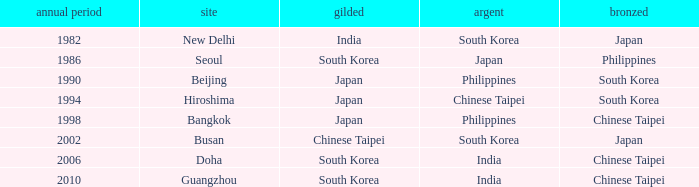Which Year is the highest one that has a Bronze of south korea, and a Silver of philippines? 1990.0. 